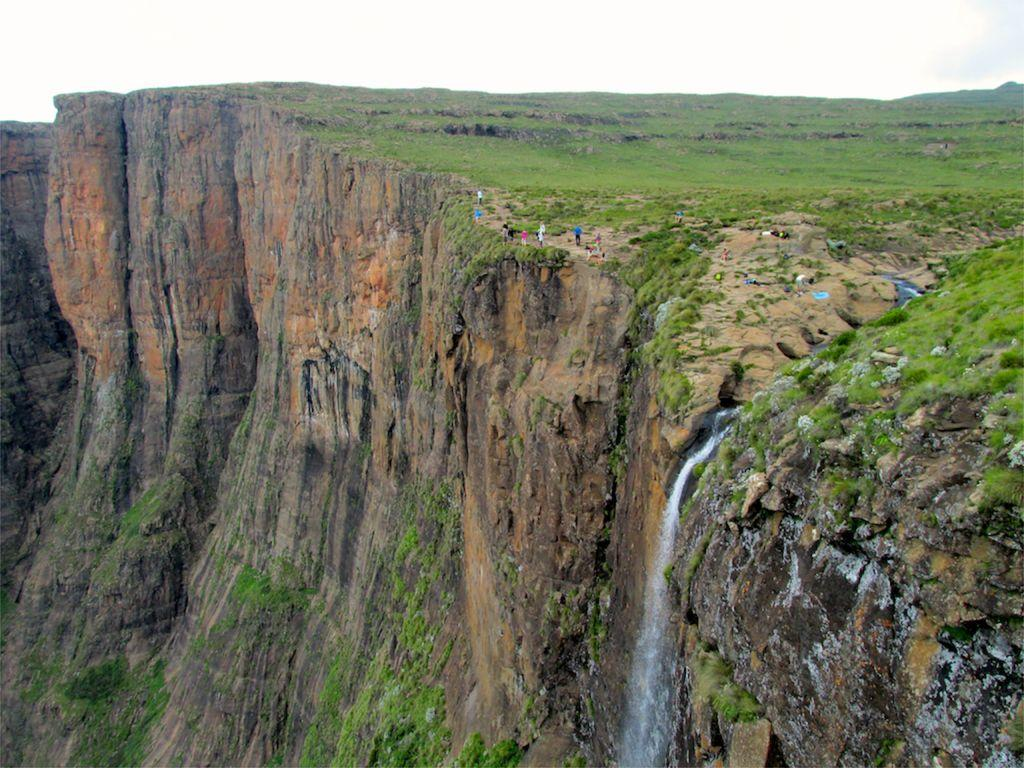What type of natural formation is present in the image? There is a mountain cliff in the image. Are there any people in the image? Yes, there are a few people in the image. What type of vegetation can be seen in the image? There is grass visible in the image. What other natural feature is present in the image? There is a waterfall in the image. What part of the natural environment is visible in the image? The sky is visible in the image. Can you hear the whistle of the river in the image? There is no river or whistling sound present in the image. How does the waterfall blow in the image? The waterfall does not blow in the image; it flows down the mountain cliff. 